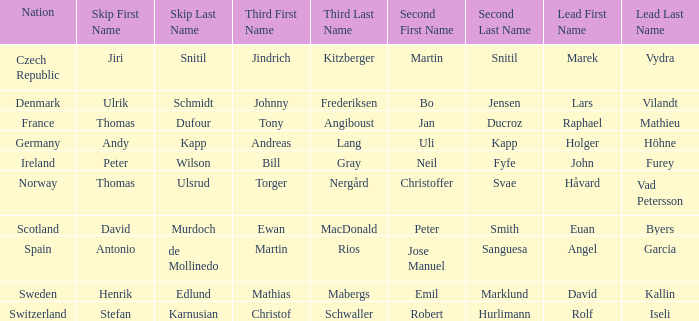Which Third has a Nation of scotland? Ewan MacDonald. 